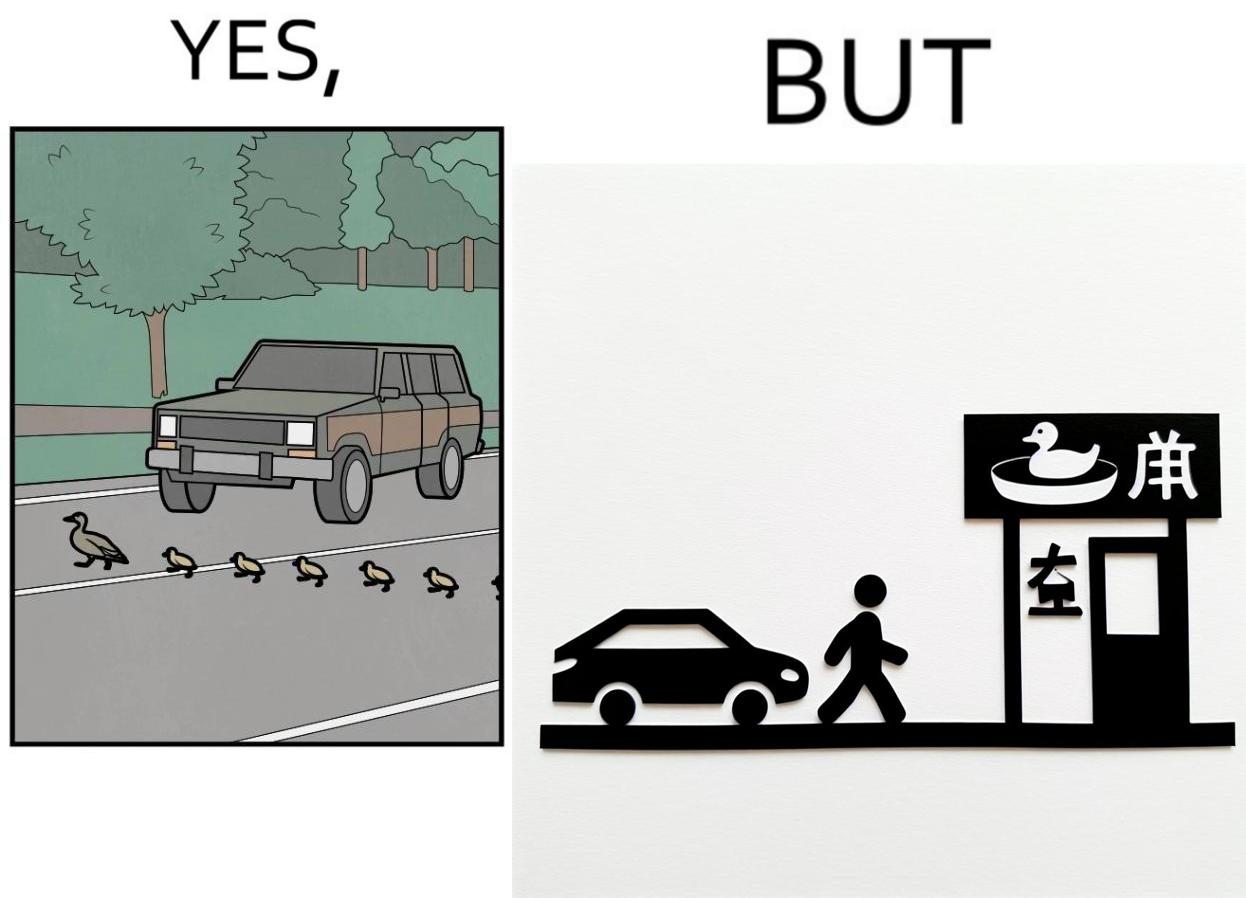Describe what you see in this image. The images are ironic since they show how a man supposedly cares for ducks since he stops his vehicle to give way to queue of ducks allowing them to safely cross a road but on the other hand he goes to a peking duck shop to buy and eat similar ducks after having them killed 